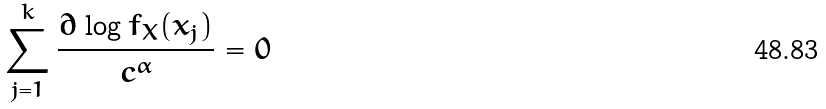Convert formula to latex. <formula><loc_0><loc_0><loc_500><loc_500>\sum _ { j = 1 } ^ { k } \frac { \partial \log f _ { X } ( x _ { j } ) } { c ^ { \alpha } } = 0</formula> 